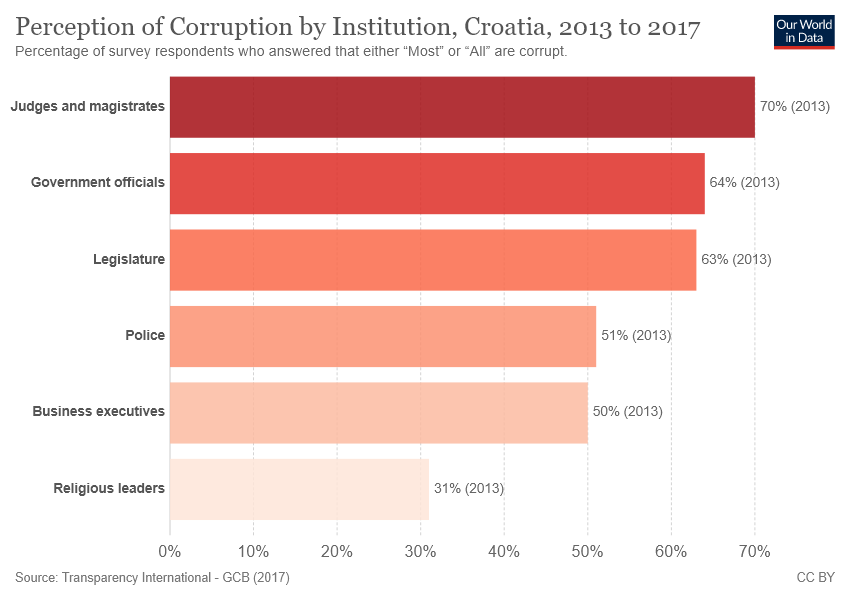Indicate a few pertinent items in this graphic. The bar chart shows 6 instances of corruption. The value of police executives in corruption is different from that of business executives. 